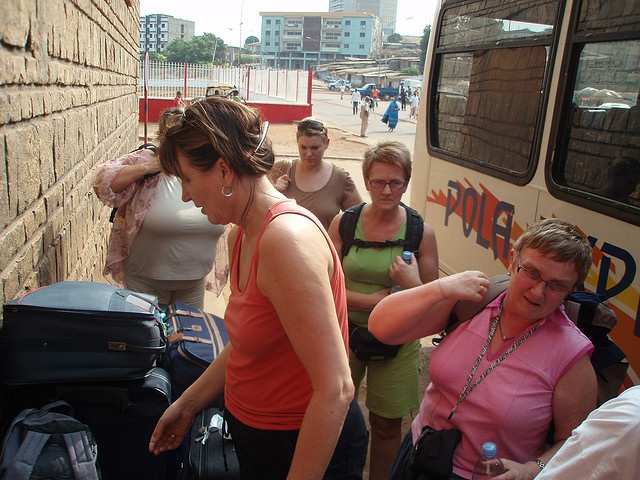Describe the objects in this image and their specific colors. I can see bus in tan, black, gray, and maroon tones, people in tan, maroon, black, and brown tones, people in tan, maroon, brown, and black tones, people in tan, black, darkgreen, maroon, and brown tones, and suitcase in tan, black, darkgray, and gray tones in this image. 